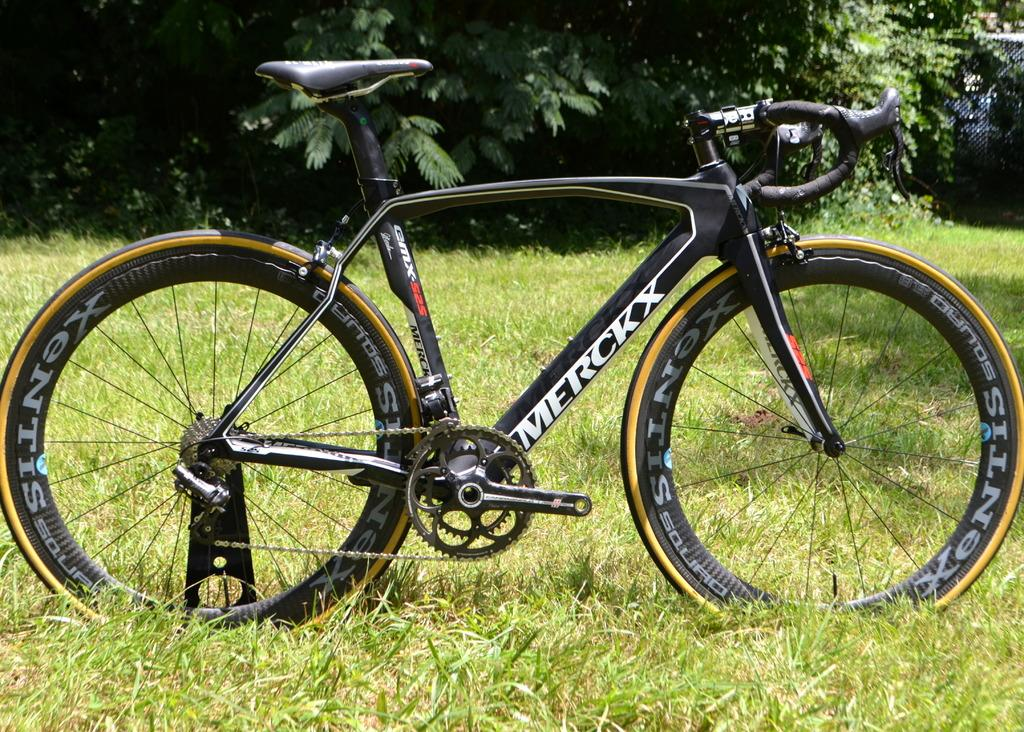What type of vegetation can be seen in the background of the image? There are trees in the background of the image. What is the texture of the background in the image? There is a mesh in the background of the image. What mode of transportation is present in the image? There is a bicycle in the image. What type of ground surface is visible at the bottom portion of the image? Green grass is visible at the bottom portion of the image. Where is the sister sitting on the bicycle in the image? There is no sister present in the image, and the bicycle is not being ridden by anyone. What type of kitty can be seen playing with the mesh in the image? There is no kitty present in the image; the mesh is in the background and not interacting with any animals. 